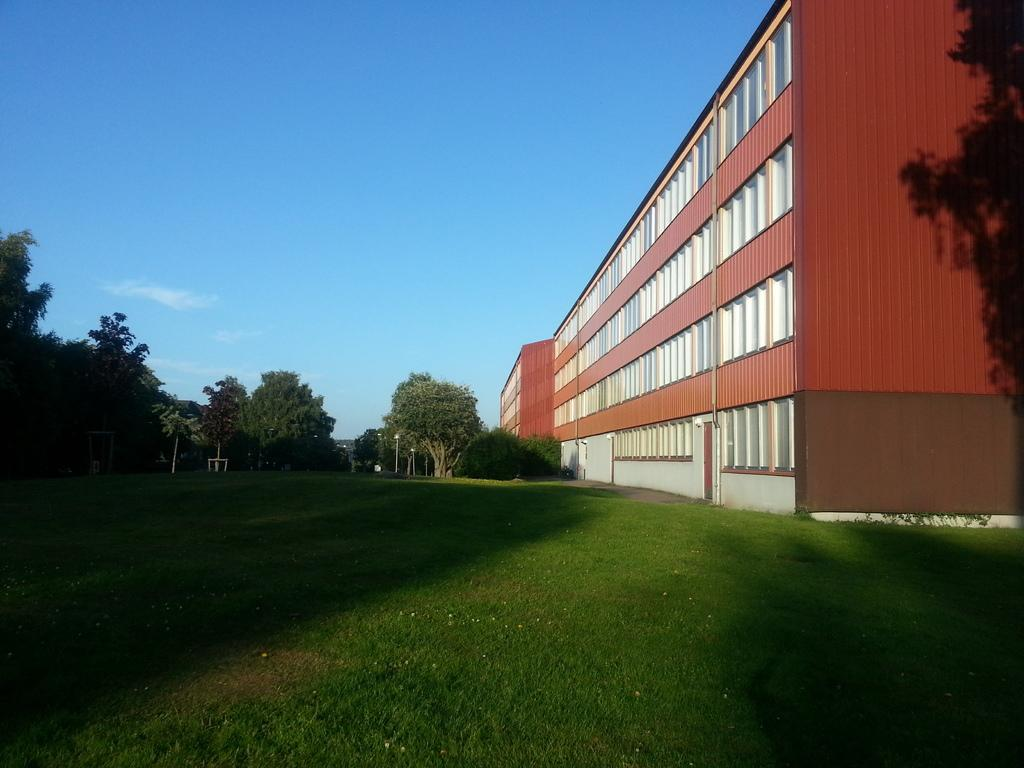What type of vegetation can be seen in the image? There are trees in the image. What type of structure is present in the image? There is a building in the image. What is the ground covered with in the image? There is grass visible in the image. What can be seen in the background of the image? There are poles and the sky visible in the background of the image. What is the current partner's name of the person in the image? There is no person present in the image, so it is not possible to determine the name of their partner. What addition can be seen in the image? There is no indication of an addition or change in the image; it shows trees, a building, grass, poles, and the sky. 